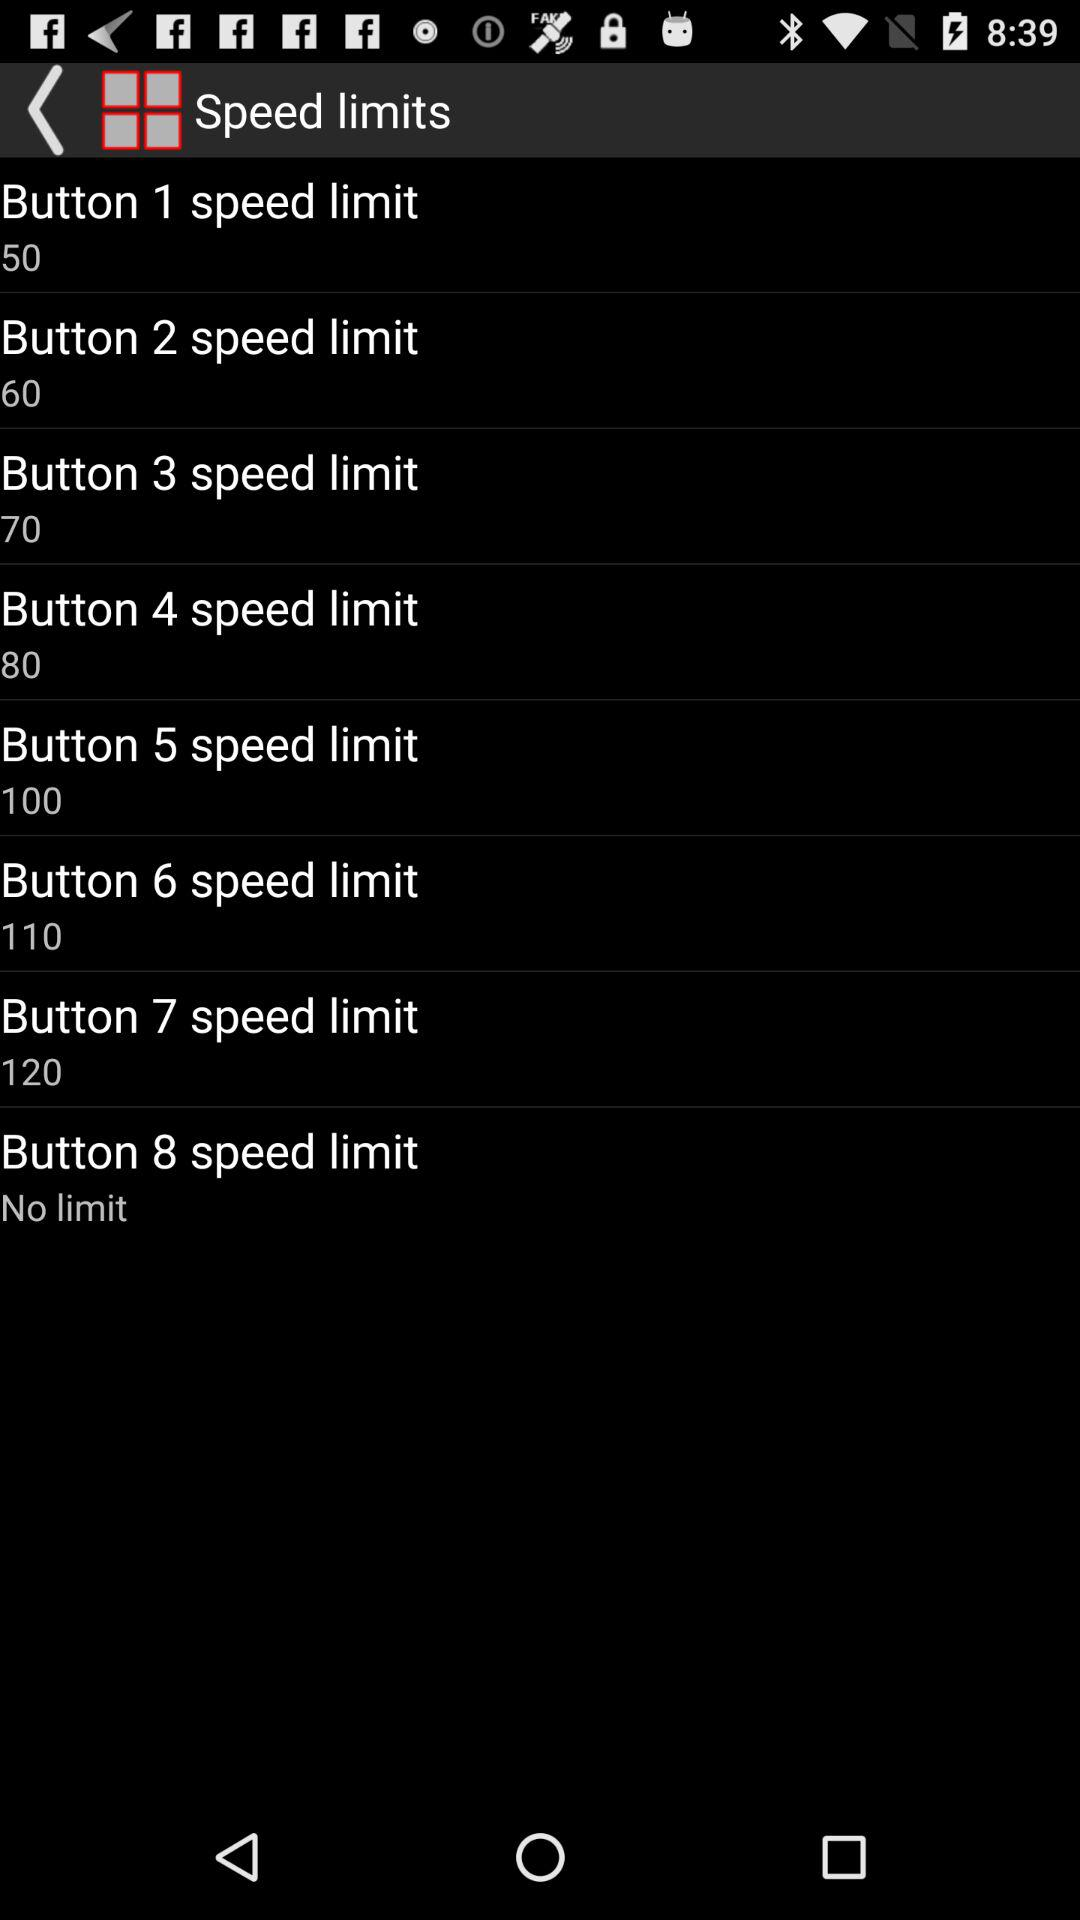How many speed limits are available?
Answer the question using a single word or phrase. 8 